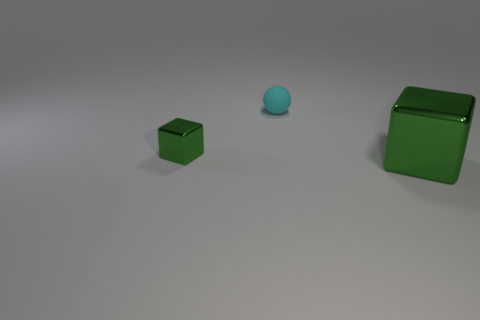What time of day does the lighting in the image suggest? The image features soft shadows with no clear indication of a direct light source, which likely means the lighting is artificial. Therefore, it doesn't suggest a particular time of day, but instead implies an indoor, controlled lighting environment. 